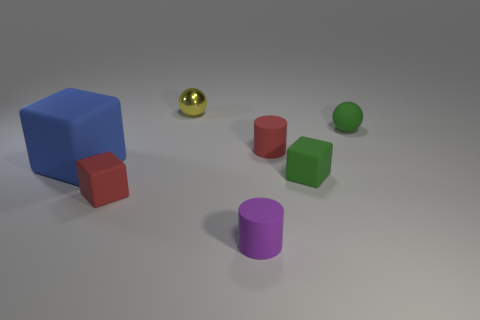What number of purple things are tiny matte objects or rubber cylinders?
Make the answer very short. 1. What number of green things are in front of the rubber sphere?
Your response must be concise. 1. What is the size of the red rubber thing that is on the right side of the red matte object to the left of the tiny red thing behind the big blue matte cube?
Your answer should be very brief. Small. Are there any matte blocks that are left of the ball left of the rubber cylinder in front of the large blue matte cube?
Give a very brief answer. Yes. Are there more blue objects than small green things?
Offer a terse response. No. What is the color of the cylinder behind the large blue block?
Your answer should be very brief. Red. Are there more tiny cylinders that are on the left side of the red matte cylinder than green shiny cylinders?
Provide a short and direct response. Yes. Are the blue thing and the small red block made of the same material?
Your answer should be very brief. Yes. What number of other objects are the same shape as the blue object?
Your answer should be compact. 2. Are there any other things that are the same material as the yellow ball?
Your response must be concise. No. 